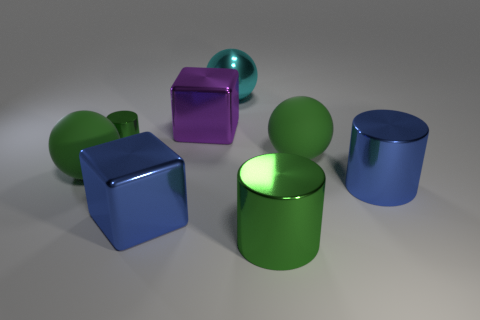What number of things are large shiny cylinders or big green matte balls on the right side of the tiny metallic cylinder?
Provide a short and direct response. 3. What size is the object that is left of the green metal cylinder left of the purple block?
Offer a terse response. Large. Are there the same number of large cyan metal spheres on the left side of the purple metal block and large shiny cylinders in front of the blue cylinder?
Provide a succinct answer. No. There is a large sphere that is behind the small green metallic object; are there any large green shiny things behind it?
Provide a succinct answer. No. What is the shape of the big cyan object that is the same material as the blue cylinder?
Provide a short and direct response. Sphere. Are there any other things that are the same color as the shiny sphere?
Keep it short and to the point. No. There is a green sphere that is on the right side of the large purple shiny block behind the large green metal object; what is its material?
Offer a terse response. Rubber. Are there any other big purple rubber objects of the same shape as the big purple object?
Keep it short and to the point. No. How many other objects are there of the same shape as the purple shiny thing?
Your response must be concise. 1. What is the shape of the large metal object that is both behind the blue metallic cube and in front of the purple metallic thing?
Your answer should be compact. Cylinder. 